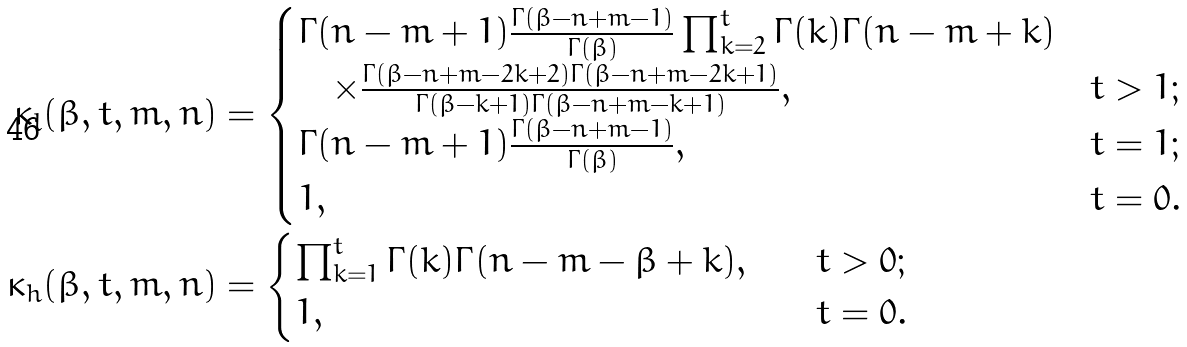<formula> <loc_0><loc_0><loc_500><loc_500>\kappa _ { l } ( \beta , t , m , n ) & = \begin{cases} \Gamma ( n - m + 1 ) \frac { \Gamma ( \beta - n + m - 1 ) } { \Gamma ( \beta ) } \prod _ { k = 2 } ^ { t } \Gamma ( k ) \Gamma ( n - m + k ) \\ \quad \times \frac { \Gamma ( \beta - n + m - 2 k + 2 ) \Gamma ( \beta - n + m - 2 k + 1 ) } { \Gamma ( \beta - k + 1 ) \Gamma ( \beta - n + m - k + 1 ) } , \quad & t > 1 ; \\ \Gamma ( n - m + 1 ) \frac { \Gamma ( \beta - n + m - 1 ) } { \Gamma ( \beta ) } , \quad & t = 1 ; \\ 1 , \quad & t = 0 . \end{cases} \\ \kappa _ { h } ( \beta , t , m , n ) & = \begin{cases} \prod _ { k = 1 } ^ { t } \Gamma ( k ) \Gamma ( n - m - \beta + k ) , \quad & t > 0 ; \\ 1 , \quad & t = 0 . \end{cases}</formula> 